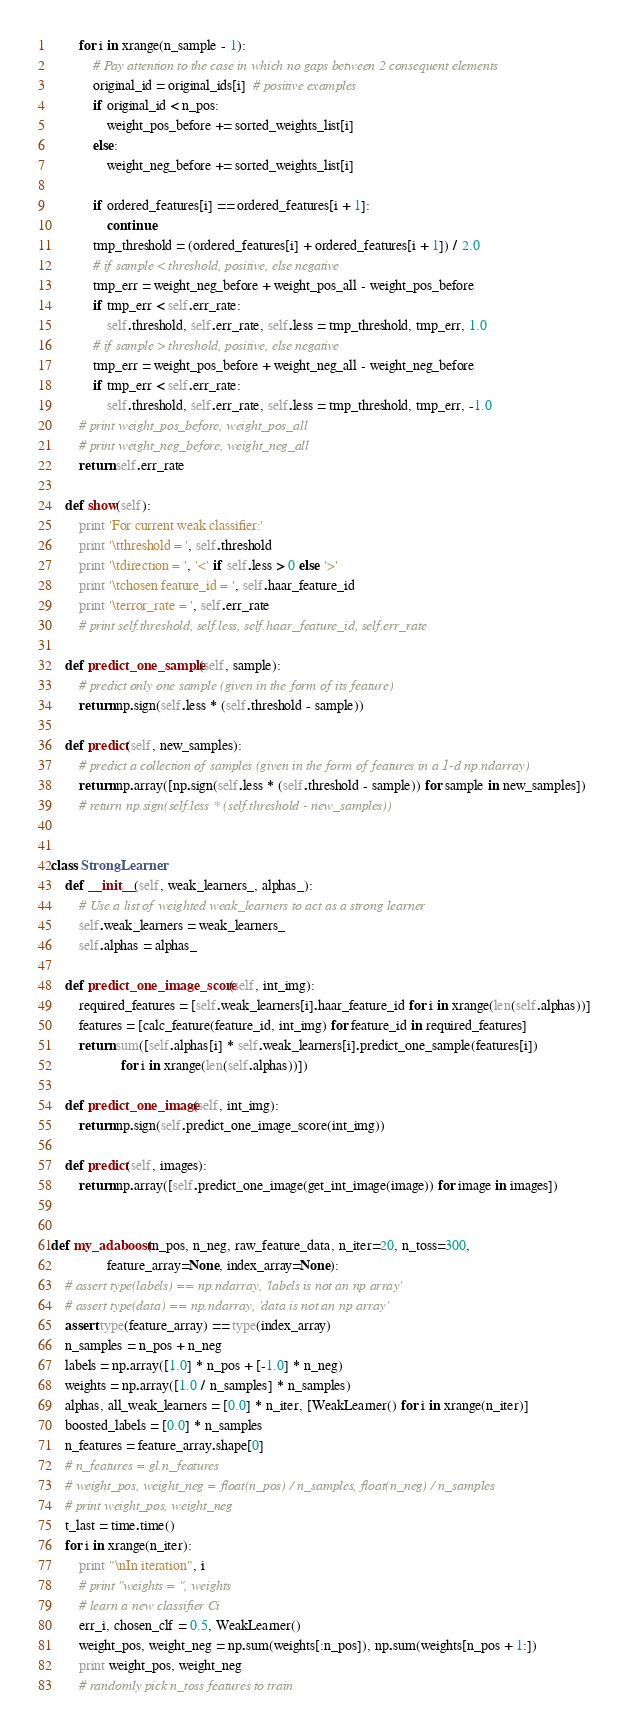<code> <loc_0><loc_0><loc_500><loc_500><_Python_>        for i in xrange(n_sample - 1):
            # Pay attention to the case in which no gaps between 2 consequent elements
            original_id = original_ids[i]  # positive examples
            if original_id < n_pos:
                weight_pos_before += sorted_weights_list[i]
            else:
                weight_neg_before += sorted_weights_list[i]

            if ordered_features[i] == ordered_features[i + 1]:
                continue
            tmp_threshold = (ordered_features[i] + ordered_features[i + 1]) / 2.0
            # if sample < threshold, positive, else negative
            tmp_err = weight_neg_before + weight_pos_all - weight_pos_before
            if tmp_err < self.err_rate:
                self.threshold, self.err_rate, self.less = tmp_threshold, tmp_err, 1.0
            # if sample > threshold, positive, else negative
            tmp_err = weight_pos_before + weight_neg_all - weight_neg_before
            if tmp_err < self.err_rate:
                self.threshold, self.err_rate, self.less = tmp_threshold, tmp_err, -1.0
        # print weight_pos_before, weight_pos_all
        # print weight_neg_before, weight_neg_all
        return self.err_rate

    def show(self):
        print 'For current weak classifier:'
        print '\tthreshold = ', self.threshold
        print '\tdirection = ', '<' if self.less > 0 else '>'
        print '\tchosen feature_id = ', self.haar_feature_id
        print '\terror_rate = ', self.err_rate
        # print self.threshold, self.less, self.haar_feature_id, self.err_rate

    def predict_one_sample(self, sample):
        # predict only one sample (given in the form of its feature)
        return np.sign(self.less * (self.threshold - sample))

    def predict(self, new_samples):
        # predict a collection of samples (given in the form of features in a 1-d np.ndarray)
        return np.array([np.sign(self.less * (self.threshold - sample)) for sample in new_samples])
        # return np.sign(self.less * (self.threshold - new_samples))


class StrongLearner:
    def __init__(self, weak_learners_, alphas_):
        # Use a list of weighted weak_learners to act as a strong learner
        self.weak_learners = weak_learners_
        self.alphas = alphas_

    def predict_one_image_score(self, int_img):
        required_features = [self.weak_learners[i].haar_feature_id for i in xrange(len(self.alphas))]
        features = [calc_feature(feature_id, int_img) for feature_id in required_features]
        return sum([self.alphas[i] * self.weak_learners[i].predict_one_sample(features[i])
                    for i in xrange(len(self.alphas))])

    def predict_one_image(self, int_img):
        return np.sign(self.predict_one_image_score(int_img))

    def predict(self, images):
        return np.array([self.predict_one_image(get_int_image(image)) for image in images])


def my_adaboost(n_pos, n_neg, raw_feature_data, n_iter=20, n_toss=300,
                feature_array=None, index_array=None):
    # assert type(labels) == np.ndarray, 'labels is not an np array'
    # assert type(data) == np.ndarray, 'data is not an np array'
    assert type(feature_array) == type(index_array)
    n_samples = n_pos + n_neg
    labels = np.array([1.0] * n_pos + [-1.0] * n_neg)
    weights = np.array([1.0 / n_samples] * n_samples)
    alphas, all_weak_learners = [0.0] * n_iter, [WeakLearner() for i in xrange(n_iter)]
    boosted_labels = [0.0] * n_samples
    n_features = feature_array.shape[0]
    # n_features = gl.n_features
    # weight_pos, weight_neg = float(n_pos) / n_samples, float(n_neg) / n_samples
    # print weight_pos, weight_neg
    t_last = time.time()
    for i in xrange(n_iter):
        print "\nIn iteration", i
        # print "weights = ", weights
        # learn a new classifier Ci
        err_i, chosen_clf = 0.5, WeakLearner()
        weight_pos, weight_neg = np.sum(weights[:n_pos]), np.sum(weights[n_pos + 1:])
        print weight_pos, weight_neg
        # randomly pick n_toss features to train</code> 